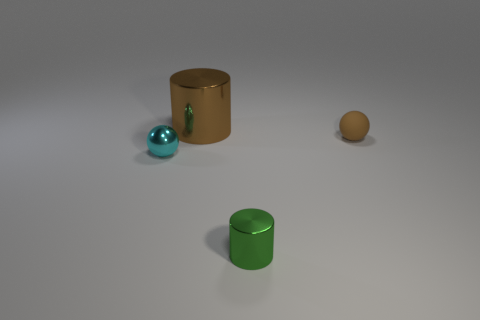Are the sphere that is left of the matte sphere and the big brown thing made of the same material?
Provide a short and direct response. Yes. How many other things are the same material as the small cyan sphere?
Give a very brief answer. 2. What is the big cylinder made of?
Keep it short and to the point. Metal. How big is the brown thing on the right side of the small cylinder?
Make the answer very short. Small. What number of things are on the left side of the tiny sphere right of the large shiny object?
Your answer should be compact. 3. Do the thing that is to the right of the green shiny cylinder and the small thing that is to the left of the brown shiny cylinder have the same shape?
Your answer should be very brief. Yes. How many shiny objects are both in front of the big shiny cylinder and to the left of the green cylinder?
Ensure brevity in your answer.  1. Is there another object of the same color as the matte thing?
Your answer should be very brief. Yes. There is a cyan object that is the same size as the green metal cylinder; what shape is it?
Your answer should be very brief. Sphere. Are there any big metal cylinders behind the big brown cylinder?
Ensure brevity in your answer.  No. 